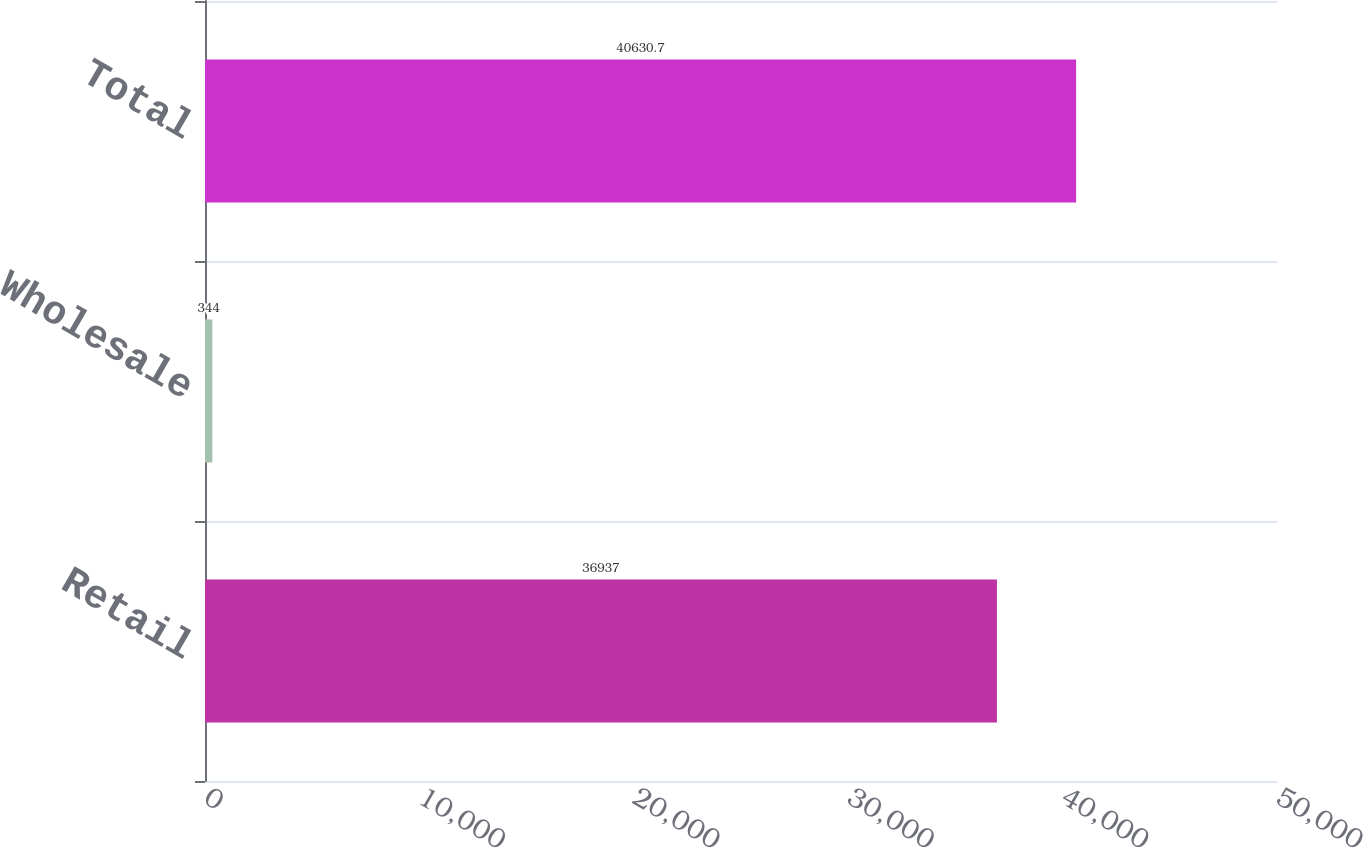<chart> <loc_0><loc_0><loc_500><loc_500><bar_chart><fcel>Retail<fcel>Wholesale<fcel>Total<nl><fcel>36937<fcel>344<fcel>40630.7<nl></chart> 